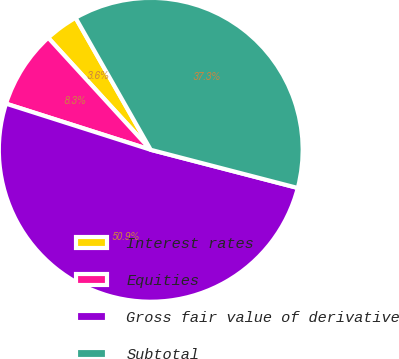Convert chart. <chart><loc_0><loc_0><loc_500><loc_500><pie_chart><fcel>Interest rates<fcel>Equities<fcel>Gross fair value of derivative<fcel>Subtotal<nl><fcel>3.56%<fcel>8.29%<fcel>50.87%<fcel>37.28%<nl></chart> 